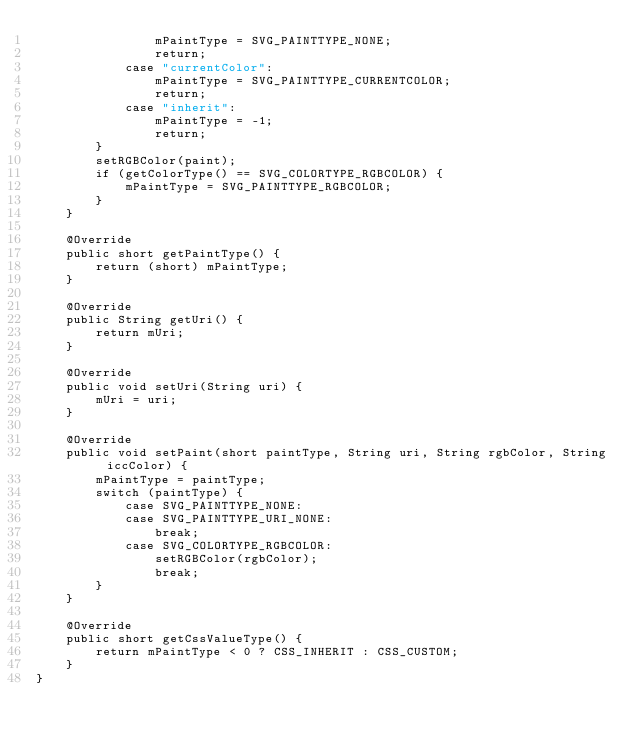<code> <loc_0><loc_0><loc_500><loc_500><_Java_>                mPaintType = SVG_PAINTTYPE_NONE;
                return;
            case "currentColor":
                mPaintType = SVG_PAINTTYPE_CURRENTCOLOR;
                return;
            case "inherit":
                mPaintType = -1;
                return;
        }
        setRGBColor(paint);
        if (getColorType() == SVG_COLORTYPE_RGBCOLOR) {
            mPaintType = SVG_PAINTTYPE_RGBCOLOR;
        }
    }

    @Override
    public short getPaintType() {
        return (short) mPaintType;
    }

    @Override
    public String getUri() {
        return mUri;
    }

    @Override
    public void setUri(String uri) {
        mUri = uri;
    }

    @Override
    public void setPaint(short paintType, String uri, String rgbColor, String iccColor) {
        mPaintType = paintType;
        switch (paintType) {
            case SVG_PAINTTYPE_NONE:
            case SVG_PAINTTYPE_URI_NONE:
                break;
            case SVG_COLORTYPE_RGBCOLOR:
                setRGBColor(rgbColor);
                break;
        }
    }

    @Override
    public short getCssValueType() {
        return mPaintType < 0 ? CSS_INHERIT : CSS_CUSTOM;
    }
}
</code> 